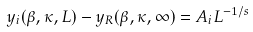<formula> <loc_0><loc_0><loc_500><loc_500>y _ { i } ( \beta , \kappa , L ) - y _ { R } ( \beta , \kappa , \infty ) = A _ { i } L ^ { - 1 / s }</formula> 